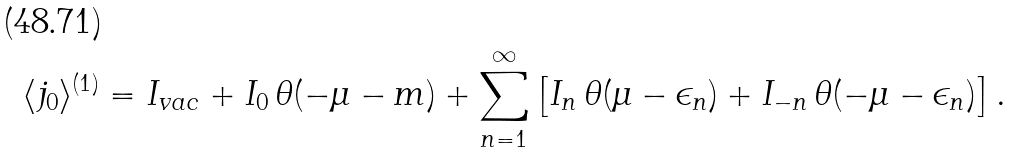Convert formula to latex. <formula><loc_0><loc_0><loc_500><loc_500>\langle j _ { 0 } \rangle ^ { ( 1 ) } = I _ { v a c } + I _ { 0 } \, \theta ( - \mu - m ) + \sum _ { n = 1 } ^ { \infty } \left [ I _ { n } \, \theta ( \mu - \epsilon _ { n } ) + I _ { - n } \, \theta ( - \mu - \epsilon _ { n } ) \right ] .</formula> 